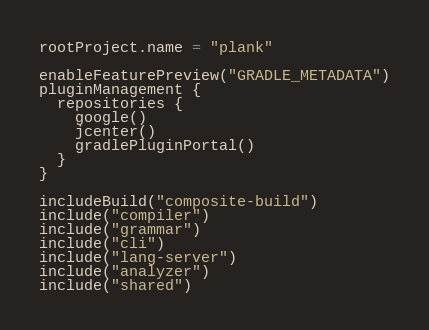Convert code to text. <code><loc_0><loc_0><loc_500><loc_500><_Kotlin_>rootProject.name = "plank"

enableFeaturePreview("GRADLE_METADATA")
pluginManagement {
  repositories {
    google()
    jcenter()
    gradlePluginPortal()
  }
}

includeBuild("composite-build")
include("compiler")
include("grammar")
include("cli")
include("lang-server")
include("analyzer")
include("shared")
</code> 